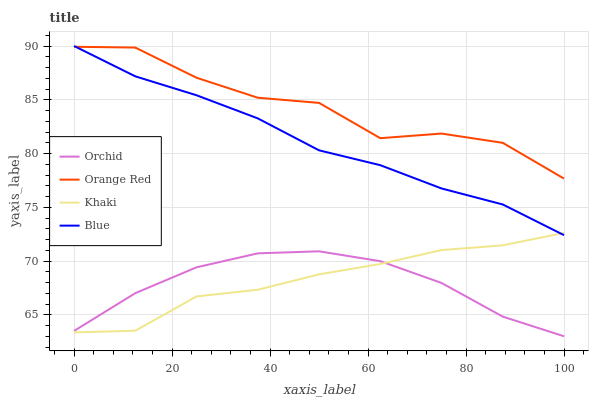Does Orchid have the minimum area under the curve?
Answer yes or no. Yes. Does Orange Red have the maximum area under the curve?
Answer yes or no. Yes. Does Khaki have the minimum area under the curve?
Answer yes or no. No. Does Khaki have the maximum area under the curve?
Answer yes or no. No. Is Blue the smoothest?
Answer yes or no. Yes. Is Orange Red the roughest?
Answer yes or no. Yes. Is Khaki the smoothest?
Answer yes or no. No. Is Khaki the roughest?
Answer yes or no. No. Does Orchid have the lowest value?
Answer yes or no. Yes. Does Khaki have the lowest value?
Answer yes or no. No. Does Blue have the highest value?
Answer yes or no. Yes. Does Khaki have the highest value?
Answer yes or no. No. Is Orchid less than Blue?
Answer yes or no. Yes. Is Orange Red greater than Orchid?
Answer yes or no. Yes. Does Khaki intersect Blue?
Answer yes or no. Yes. Is Khaki less than Blue?
Answer yes or no. No. Is Khaki greater than Blue?
Answer yes or no. No. Does Orchid intersect Blue?
Answer yes or no. No. 